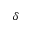Convert formula to latex. <formula><loc_0><loc_0><loc_500><loc_500>\delta</formula> 